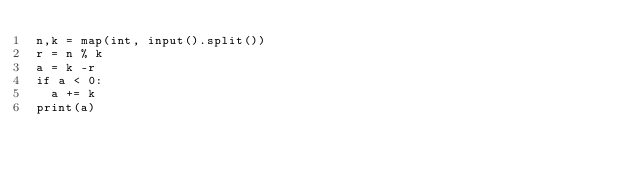Convert code to text. <code><loc_0><loc_0><loc_500><loc_500><_Python_>n,k = map(int, input().split())
r = n % k
a = k -r
if a < 0:
	a += k
print(a)
</code> 